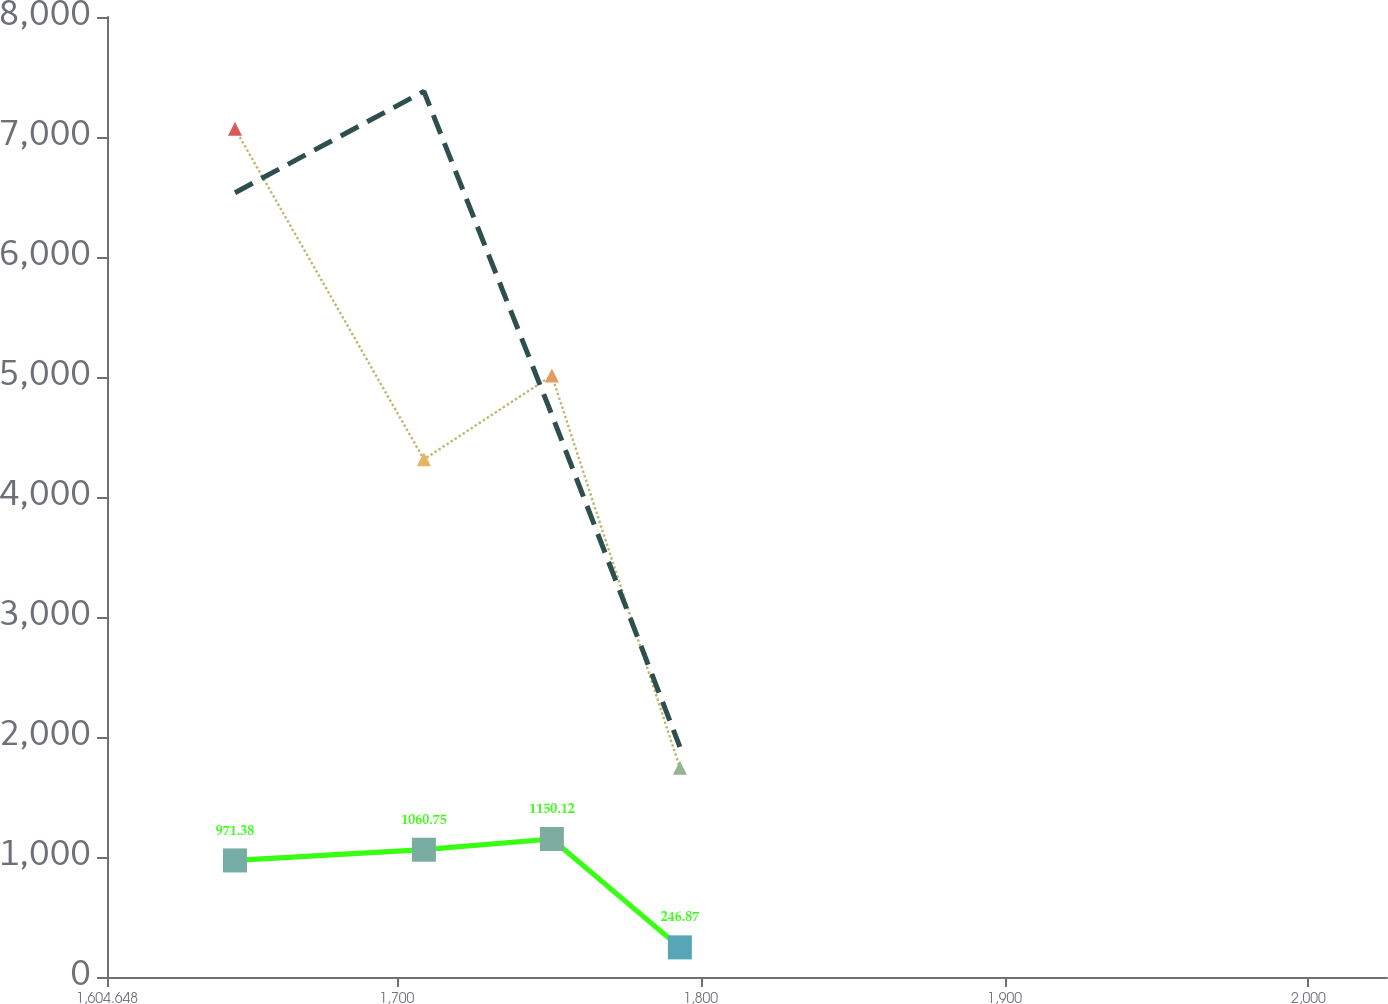Convert chart to OTSL. <chart><loc_0><loc_0><loc_500><loc_500><line_chart><ecel><fcel>Stock Options<fcel>Total<fcel>Restricted Stock<nl><fcel>1646.77<fcel>7068.96<fcel>971.38<fcel>6535.54<nl><fcel>1708.93<fcel>4313.64<fcel>1060.75<fcel>7380.53<nl><fcel>1751.05<fcel>5011.58<fcel>1150.12<fcel>4684.64<nl><fcel>1793.17<fcel>1743.87<fcel>246.87<fcel>1917.73<nl><fcel>2067.99<fcel>89.56<fcel>157.5<fcel>214.59<nl></chart> 